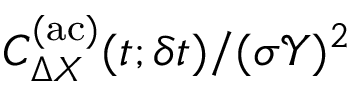<formula> <loc_0><loc_0><loc_500><loc_500>C _ { \Delta X } ^ { ( a c ) } ( t ; \delta t ) / ( \sigma \mathcal { Y } ) ^ { 2 }</formula> 